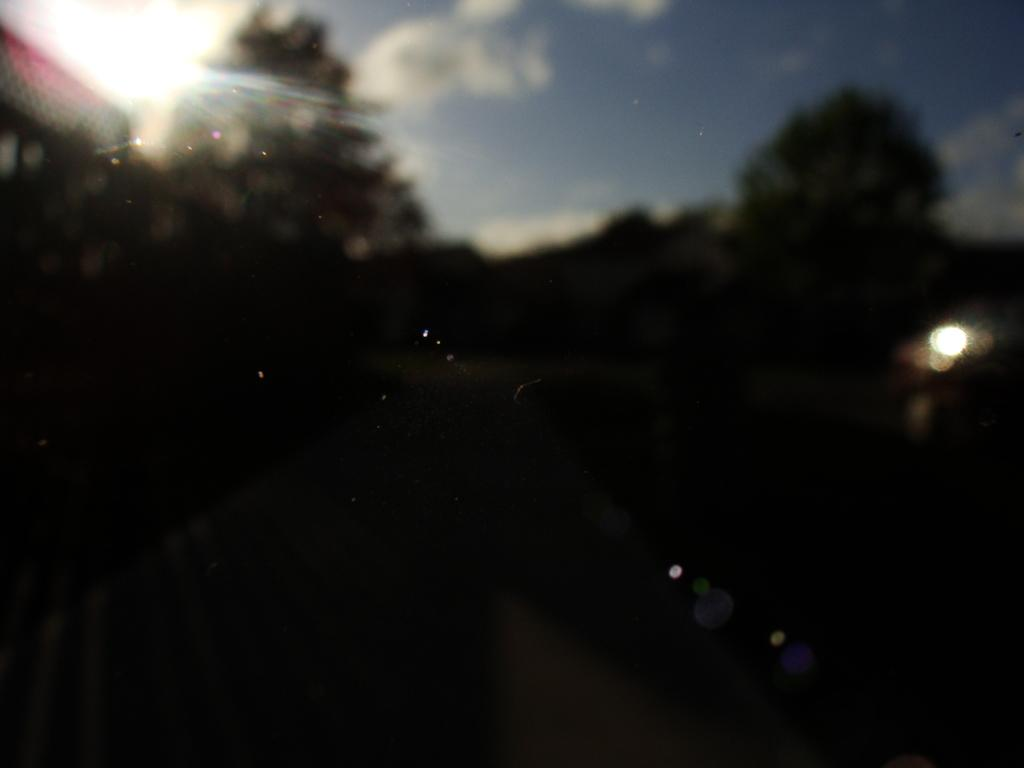What is the overall quality of the image? The image appears to be blurred. What type of vegetation can be seen in the image? There are trees visible in the image. What is visible at the top of the image? The sky is visible at the top of the image. What can be observed in the sky? Clouds are present in the sky. How many times does the wax curve in the image? There is no wax or curve present in the image. What type of lift is visible in the image? There is no lift present in the image. 